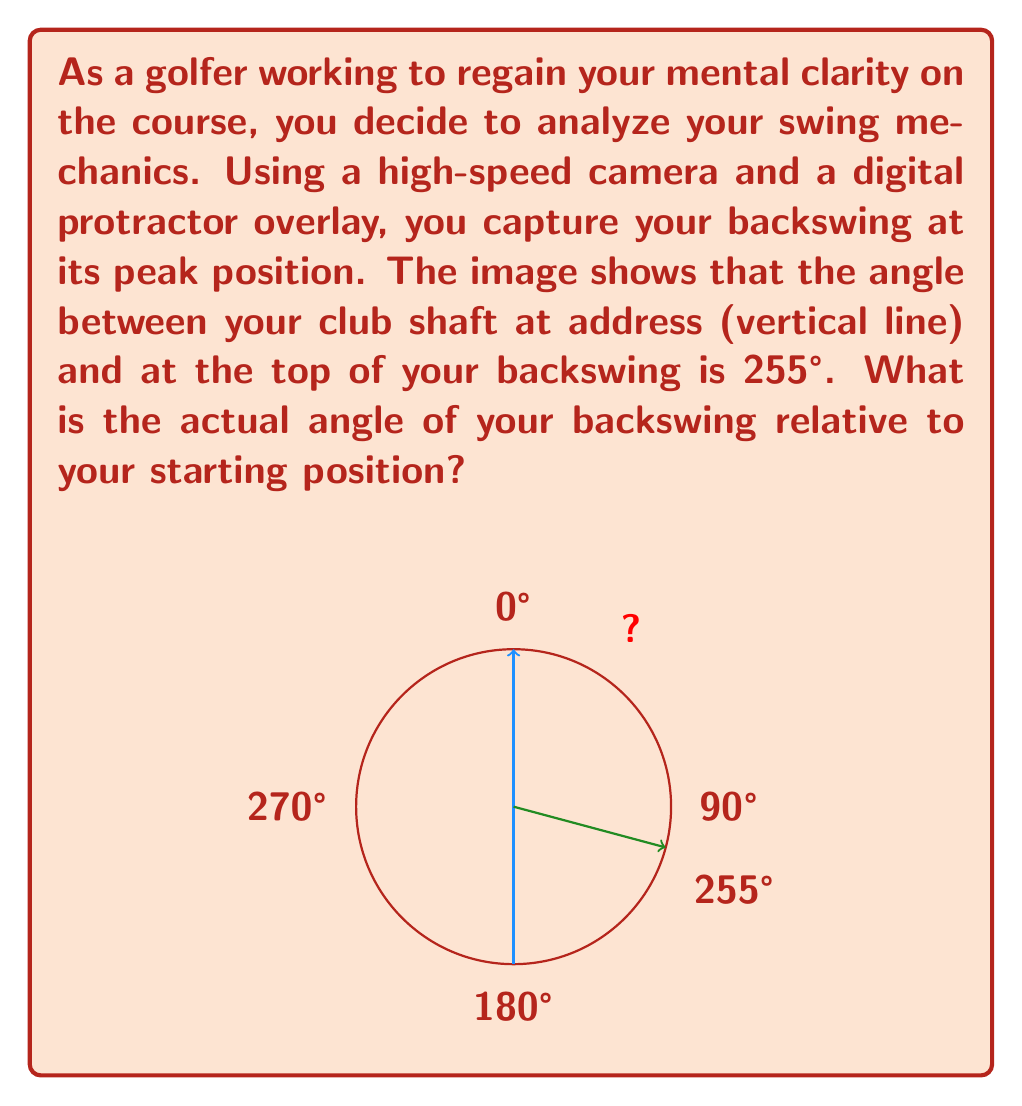Could you help me with this problem? To solve this problem, we need to understand that the protractor measures angles in a clockwise direction from the vertical (0°) position. However, we're interested in the angle of the backswing from the starting position, which is measured counterclockwise.

Step 1: Recognize that a full circle is 360°.

Step 2: The angle measured (255°) represents the clockwise angle from the vertical to the club's position at the top of the backswing.

Step 3: To find the angle of the backswing from the starting position, we need to subtract this measured angle from 360°:

$$360° - 255° = 105°$$

This calculation gives us the counterclockwise angle from the vertical starting position to the club's position at the top of the backswing.

Step 4: Verify the result:
- If we rotate 255° clockwise, we reach the same point as rotating 105° counterclockwise.
- 105° is indeed the smaller angle between the two positions, which makes sense for a golf swing.

Therefore, the actual angle of the backswing relative to the starting position is 105°.
Answer: 105° 